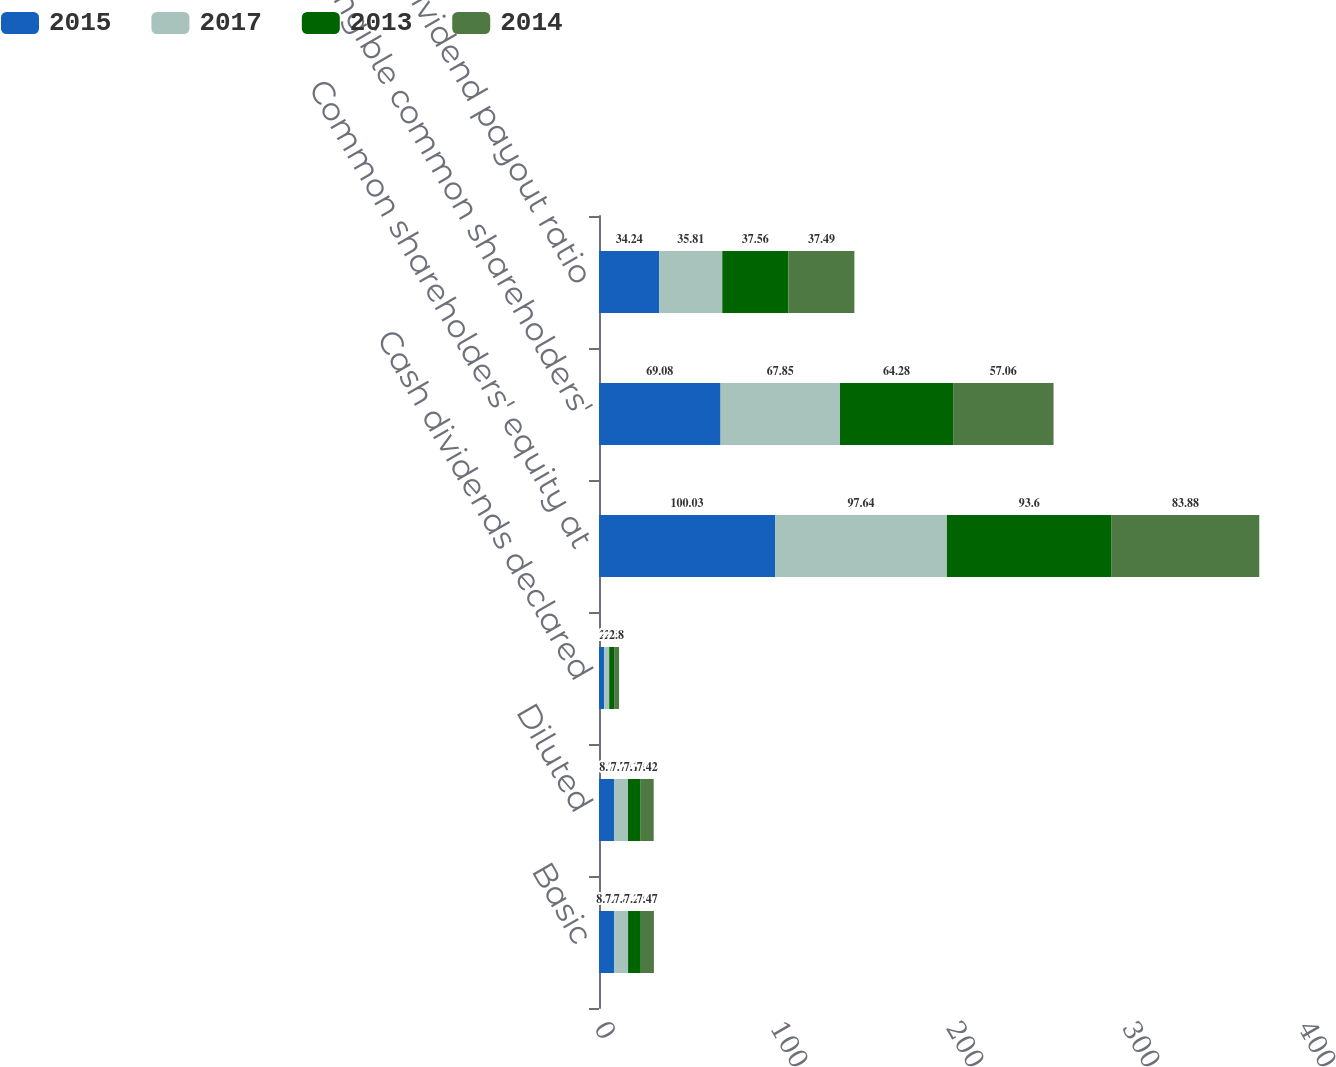<chart> <loc_0><loc_0><loc_500><loc_500><stacked_bar_chart><ecel><fcel>Basic<fcel>Diluted<fcel>Cash dividends declared<fcel>Common shareholders' equity at<fcel>Tangible common shareholders'<fcel>Dividend payout ratio<nl><fcel>2015<fcel>8.72<fcel>8.7<fcel>3<fcel>100.03<fcel>69.08<fcel>34.24<nl><fcel>2017<fcel>7.8<fcel>7.78<fcel>2.8<fcel>97.64<fcel>67.85<fcel>35.81<nl><fcel>2013<fcel>7.22<fcel>7.18<fcel>2.8<fcel>93.6<fcel>64.28<fcel>37.56<nl><fcel>2014<fcel>7.47<fcel>7.42<fcel>2.8<fcel>83.88<fcel>57.06<fcel>37.49<nl></chart> 